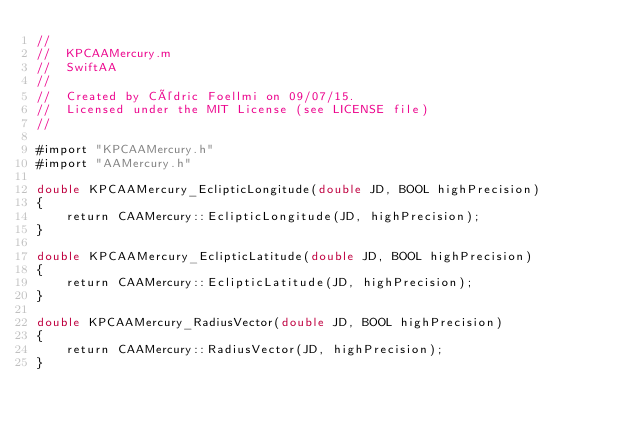Convert code to text. <code><loc_0><loc_0><loc_500><loc_500><_ObjectiveC_>//
//  KPCAAMercury.m
//  SwiftAA
//
//  Created by Cédric Foellmi on 09/07/15.
//  Licensed under the MIT License (see LICENSE file)
//

#import "KPCAAMercury.h"
#import "AAMercury.h"

double KPCAAMercury_EclipticLongitude(double JD, BOOL highPrecision)
{
    return CAAMercury::EclipticLongitude(JD, highPrecision);
}

double KPCAAMercury_EclipticLatitude(double JD, BOOL highPrecision)
{
    return CAAMercury::EclipticLatitude(JD, highPrecision);
}

double KPCAAMercury_RadiusVector(double JD, BOOL highPrecision)
{
    return CAAMercury::RadiusVector(JD, highPrecision);
}

</code> 